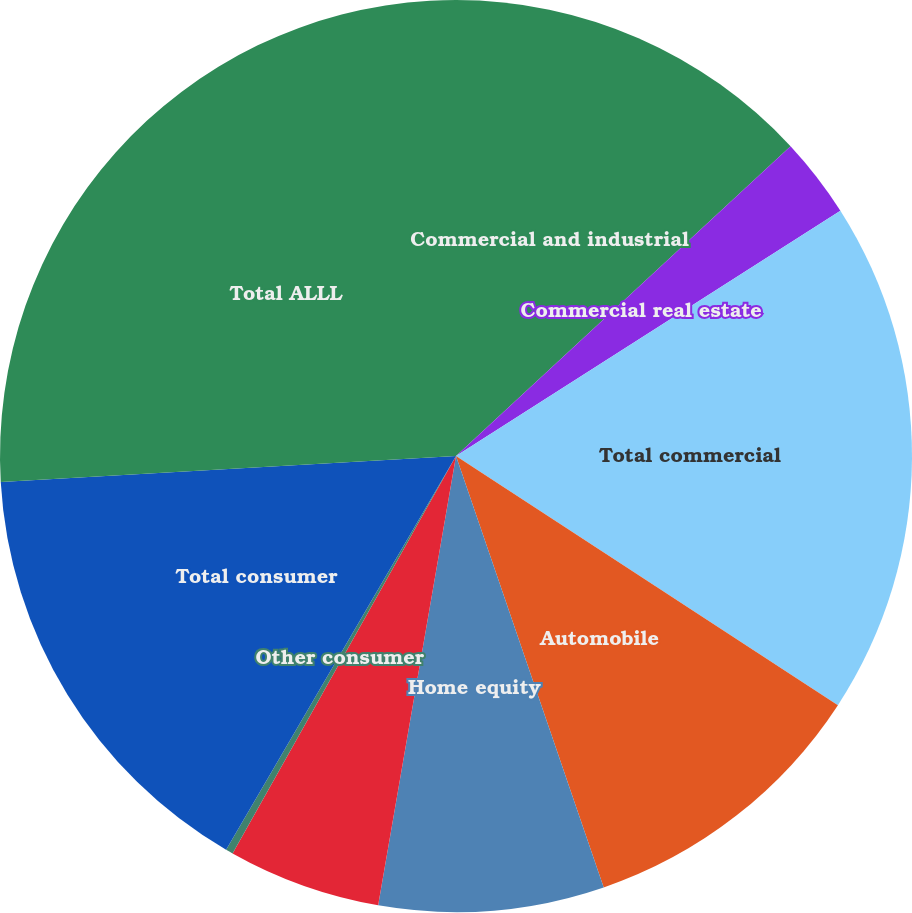Convert chart to OTSL. <chart><loc_0><loc_0><loc_500><loc_500><pie_chart><fcel>Commercial and industrial<fcel>Commercial real estate<fcel>Total commercial<fcel>Automobile<fcel>Home equity<fcel>Residential mortgage<fcel>Other consumer<fcel>Total consumer<fcel>Total ALLL<nl><fcel>13.11%<fcel>2.85%<fcel>18.24%<fcel>10.55%<fcel>7.98%<fcel>5.42%<fcel>0.26%<fcel>15.68%<fcel>25.91%<nl></chart> 